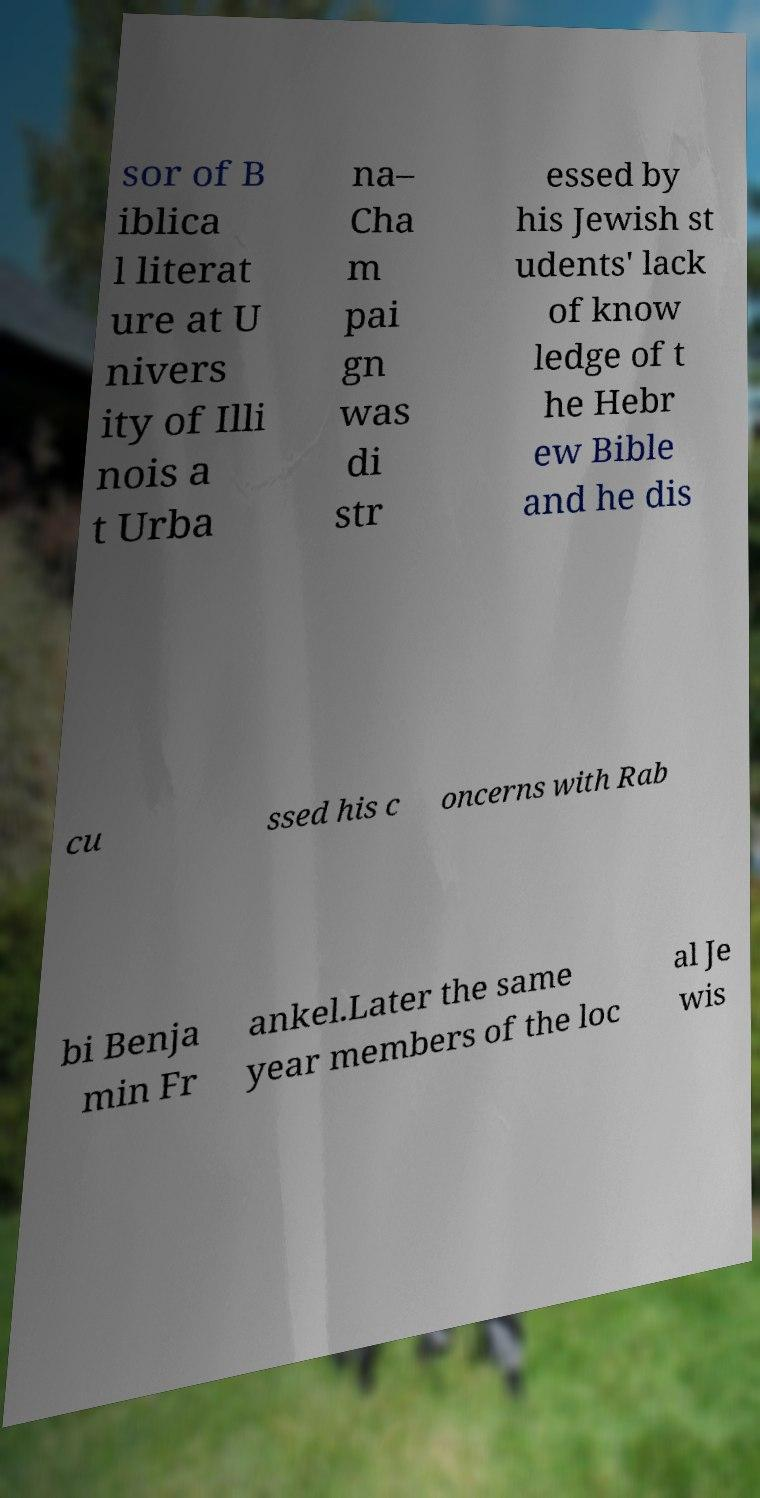Can you read and provide the text displayed in the image?This photo seems to have some interesting text. Can you extract and type it out for me? sor of B iblica l literat ure at U nivers ity of Illi nois a t Urba na– Cha m pai gn was di str essed by his Jewish st udents' lack of know ledge of t he Hebr ew Bible and he dis cu ssed his c oncerns with Rab bi Benja min Fr ankel.Later the same year members of the loc al Je wis 